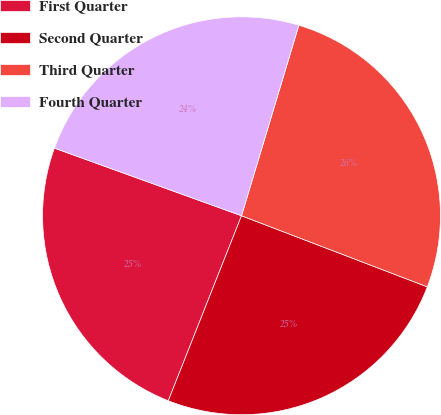Convert chart. <chart><loc_0><loc_0><loc_500><loc_500><pie_chart><fcel>First Quarter<fcel>Second Quarter<fcel>Third Quarter<fcel>Fourth Quarter<nl><fcel>24.52%<fcel>25.18%<fcel>26.16%<fcel>24.13%<nl></chart> 